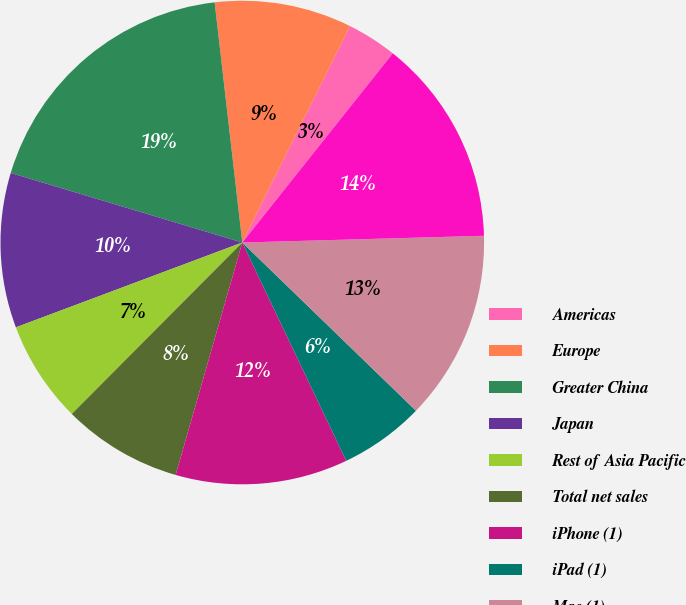Convert chart. <chart><loc_0><loc_0><loc_500><loc_500><pie_chart><fcel>Americas<fcel>Europe<fcel>Greater China<fcel>Japan<fcel>Rest of Asia Pacific<fcel>Total net sales<fcel>iPhone (1)<fcel>iPad (1)<fcel>Mac (1)<fcel>Services (2)<nl><fcel>3.34%<fcel>9.18%<fcel>18.53%<fcel>10.35%<fcel>6.84%<fcel>8.01%<fcel>11.52%<fcel>5.68%<fcel>12.69%<fcel>13.86%<nl></chart> 